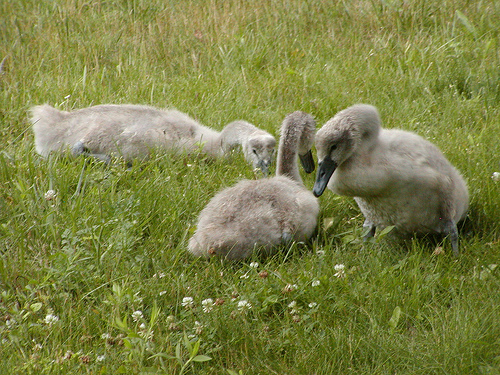<image>
Can you confirm if the duck is on the grass? Yes. Looking at the image, I can see the duck is positioned on top of the grass, with the grass providing support. 